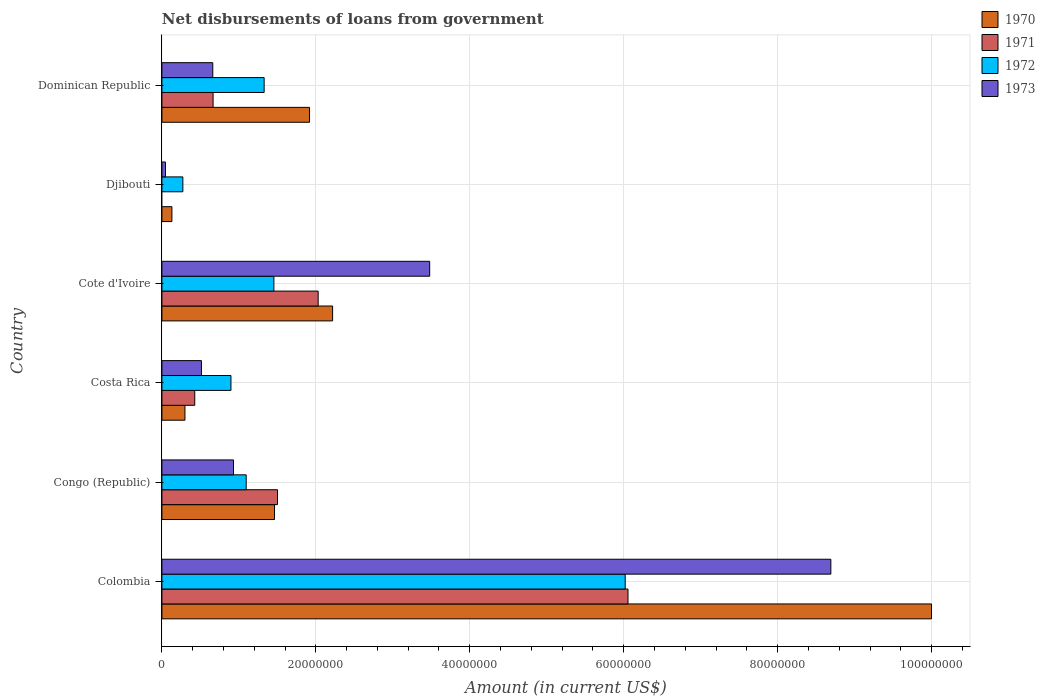How many different coloured bars are there?
Provide a succinct answer. 4. Are the number of bars per tick equal to the number of legend labels?
Your response must be concise. No. How many bars are there on the 3rd tick from the bottom?
Provide a succinct answer. 4. What is the label of the 6th group of bars from the top?
Keep it short and to the point. Colombia. What is the amount of loan disbursed from government in 1971 in Cote d'Ivoire?
Ensure brevity in your answer.  2.03e+07. Across all countries, what is the maximum amount of loan disbursed from government in 1973?
Offer a very short reply. 8.69e+07. Across all countries, what is the minimum amount of loan disbursed from government in 1971?
Make the answer very short. 0. In which country was the amount of loan disbursed from government in 1971 maximum?
Provide a succinct answer. Colombia. What is the total amount of loan disbursed from government in 1973 in the graph?
Keep it short and to the point. 1.43e+08. What is the difference between the amount of loan disbursed from government in 1973 in Colombia and that in Dominican Republic?
Ensure brevity in your answer.  8.03e+07. What is the difference between the amount of loan disbursed from government in 1970 in Dominican Republic and the amount of loan disbursed from government in 1972 in Djibouti?
Your answer should be very brief. 1.65e+07. What is the average amount of loan disbursed from government in 1971 per country?
Make the answer very short. 1.78e+07. What is the difference between the amount of loan disbursed from government in 1971 and amount of loan disbursed from government in 1973 in Dominican Republic?
Keep it short and to the point. 3.80e+04. In how many countries, is the amount of loan disbursed from government in 1970 greater than 68000000 US$?
Make the answer very short. 1. What is the ratio of the amount of loan disbursed from government in 1971 in Colombia to that in Costa Rica?
Give a very brief answer. 14.19. Is the amount of loan disbursed from government in 1970 in Costa Rica less than that in Dominican Republic?
Provide a succinct answer. Yes. Is the difference between the amount of loan disbursed from government in 1971 in Cote d'Ivoire and Dominican Republic greater than the difference between the amount of loan disbursed from government in 1973 in Cote d'Ivoire and Dominican Republic?
Ensure brevity in your answer.  No. What is the difference between the highest and the second highest amount of loan disbursed from government in 1970?
Provide a short and direct response. 7.78e+07. What is the difference between the highest and the lowest amount of loan disbursed from government in 1973?
Provide a succinct answer. 8.64e+07. In how many countries, is the amount of loan disbursed from government in 1971 greater than the average amount of loan disbursed from government in 1971 taken over all countries?
Offer a terse response. 2. How many bars are there?
Give a very brief answer. 23. Are all the bars in the graph horizontal?
Your answer should be very brief. Yes. Does the graph contain any zero values?
Provide a succinct answer. Yes. Does the graph contain grids?
Provide a succinct answer. Yes. How many legend labels are there?
Your response must be concise. 4. How are the legend labels stacked?
Your answer should be compact. Vertical. What is the title of the graph?
Make the answer very short. Net disbursements of loans from government. What is the label or title of the Y-axis?
Provide a short and direct response. Country. What is the Amount (in current US$) of 1970 in Colombia?
Offer a terse response. 1.00e+08. What is the Amount (in current US$) of 1971 in Colombia?
Give a very brief answer. 6.06e+07. What is the Amount (in current US$) in 1972 in Colombia?
Ensure brevity in your answer.  6.02e+07. What is the Amount (in current US$) in 1973 in Colombia?
Provide a succinct answer. 8.69e+07. What is the Amount (in current US$) in 1970 in Congo (Republic)?
Provide a short and direct response. 1.46e+07. What is the Amount (in current US$) in 1971 in Congo (Republic)?
Offer a very short reply. 1.50e+07. What is the Amount (in current US$) of 1972 in Congo (Republic)?
Your answer should be compact. 1.10e+07. What is the Amount (in current US$) of 1973 in Congo (Republic)?
Offer a terse response. 9.30e+06. What is the Amount (in current US$) of 1970 in Costa Rica?
Your answer should be compact. 3.00e+06. What is the Amount (in current US$) of 1971 in Costa Rica?
Offer a terse response. 4.27e+06. What is the Amount (in current US$) in 1972 in Costa Rica?
Your answer should be very brief. 8.97e+06. What is the Amount (in current US$) of 1973 in Costa Rica?
Offer a terse response. 5.14e+06. What is the Amount (in current US$) in 1970 in Cote d'Ivoire?
Your answer should be very brief. 2.22e+07. What is the Amount (in current US$) in 1971 in Cote d'Ivoire?
Give a very brief answer. 2.03e+07. What is the Amount (in current US$) of 1972 in Cote d'Ivoire?
Your response must be concise. 1.45e+07. What is the Amount (in current US$) in 1973 in Cote d'Ivoire?
Provide a short and direct response. 3.48e+07. What is the Amount (in current US$) of 1970 in Djibouti?
Provide a short and direct response. 1.30e+06. What is the Amount (in current US$) in 1971 in Djibouti?
Your answer should be compact. 0. What is the Amount (in current US$) of 1972 in Djibouti?
Your answer should be very brief. 2.72e+06. What is the Amount (in current US$) in 1973 in Djibouti?
Your response must be concise. 4.68e+05. What is the Amount (in current US$) in 1970 in Dominican Republic?
Your answer should be compact. 1.92e+07. What is the Amount (in current US$) in 1971 in Dominican Republic?
Your response must be concise. 6.65e+06. What is the Amount (in current US$) of 1972 in Dominican Republic?
Your response must be concise. 1.33e+07. What is the Amount (in current US$) in 1973 in Dominican Republic?
Give a very brief answer. 6.61e+06. Across all countries, what is the maximum Amount (in current US$) in 1970?
Your answer should be compact. 1.00e+08. Across all countries, what is the maximum Amount (in current US$) of 1971?
Your answer should be very brief. 6.06e+07. Across all countries, what is the maximum Amount (in current US$) of 1972?
Your answer should be compact. 6.02e+07. Across all countries, what is the maximum Amount (in current US$) of 1973?
Your response must be concise. 8.69e+07. Across all countries, what is the minimum Amount (in current US$) of 1970?
Offer a very short reply. 1.30e+06. Across all countries, what is the minimum Amount (in current US$) of 1971?
Your answer should be compact. 0. Across all countries, what is the minimum Amount (in current US$) of 1972?
Your answer should be very brief. 2.72e+06. Across all countries, what is the minimum Amount (in current US$) in 1973?
Provide a short and direct response. 4.68e+05. What is the total Amount (in current US$) in 1970 in the graph?
Provide a succinct answer. 1.60e+08. What is the total Amount (in current US$) of 1971 in the graph?
Offer a terse response. 1.07e+08. What is the total Amount (in current US$) of 1972 in the graph?
Keep it short and to the point. 1.11e+08. What is the total Amount (in current US$) of 1973 in the graph?
Your response must be concise. 1.43e+08. What is the difference between the Amount (in current US$) of 1970 in Colombia and that in Congo (Republic)?
Offer a terse response. 8.54e+07. What is the difference between the Amount (in current US$) of 1971 in Colombia and that in Congo (Republic)?
Your answer should be compact. 4.55e+07. What is the difference between the Amount (in current US$) in 1972 in Colombia and that in Congo (Republic)?
Your answer should be very brief. 4.92e+07. What is the difference between the Amount (in current US$) in 1973 in Colombia and that in Congo (Republic)?
Your answer should be compact. 7.76e+07. What is the difference between the Amount (in current US$) in 1970 in Colombia and that in Costa Rica?
Your response must be concise. 9.70e+07. What is the difference between the Amount (in current US$) in 1971 in Colombia and that in Costa Rica?
Provide a short and direct response. 5.63e+07. What is the difference between the Amount (in current US$) of 1972 in Colombia and that in Costa Rica?
Keep it short and to the point. 5.12e+07. What is the difference between the Amount (in current US$) in 1973 in Colombia and that in Costa Rica?
Provide a succinct answer. 8.18e+07. What is the difference between the Amount (in current US$) of 1970 in Colombia and that in Cote d'Ivoire?
Provide a succinct answer. 7.78e+07. What is the difference between the Amount (in current US$) in 1971 in Colombia and that in Cote d'Ivoire?
Make the answer very short. 4.03e+07. What is the difference between the Amount (in current US$) of 1972 in Colombia and that in Cote d'Ivoire?
Your response must be concise. 4.56e+07. What is the difference between the Amount (in current US$) in 1973 in Colombia and that in Cote d'Ivoire?
Your answer should be compact. 5.21e+07. What is the difference between the Amount (in current US$) in 1970 in Colombia and that in Djibouti?
Ensure brevity in your answer.  9.87e+07. What is the difference between the Amount (in current US$) in 1972 in Colombia and that in Djibouti?
Ensure brevity in your answer.  5.75e+07. What is the difference between the Amount (in current US$) in 1973 in Colombia and that in Djibouti?
Offer a terse response. 8.64e+07. What is the difference between the Amount (in current US$) of 1970 in Colombia and that in Dominican Republic?
Your answer should be compact. 8.08e+07. What is the difference between the Amount (in current US$) in 1971 in Colombia and that in Dominican Republic?
Give a very brief answer. 5.39e+07. What is the difference between the Amount (in current US$) of 1972 in Colombia and that in Dominican Republic?
Give a very brief answer. 4.69e+07. What is the difference between the Amount (in current US$) of 1973 in Colombia and that in Dominican Republic?
Provide a succinct answer. 8.03e+07. What is the difference between the Amount (in current US$) of 1970 in Congo (Republic) and that in Costa Rica?
Give a very brief answer. 1.16e+07. What is the difference between the Amount (in current US$) of 1971 in Congo (Republic) and that in Costa Rica?
Offer a terse response. 1.08e+07. What is the difference between the Amount (in current US$) of 1972 in Congo (Republic) and that in Costa Rica?
Make the answer very short. 1.98e+06. What is the difference between the Amount (in current US$) in 1973 in Congo (Republic) and that in Costa Rica?
Offer a terse response. 4.16e+06. What is the difference between the Amount (in current US$) of 1970 in Congo (Republic) and that in Cote d'Ivoire?
Your response must be concise. -7.54e+06. What is the difference between the Amount (in current US$) in 1971 in Congo (Republic) and that in Cote d'Ivoire?
Give a very brief answer. -5.28e+06. What is the difference between the Amount (in current US$) in 1972 in Congo (Republic) and that in Cote d'Ivoire?
Give a very brief answer. -3.60e+06. What is the difference between the Amount (in current US$) in 1973 in Congo (Republic) and that in Cote d'Ivoire?
Give a very brief answer. -2.55e+07. What is the difference between the Amount (in current US$) in 1970 in Congo (Republic) and that in Djibouti?
Give a very brief answer. 1.33e+07. What is the difference between the Amount (in current US$) of 1972 in Congo (Republic) and that in Djibouti?
Provide a short and direct response. 8.23e+06. What is the difference between the Amount (in current US$) of 1973 in Congo (Republic) and that in Djibouti?
Make the answer very short. 8.83e+06. What is the difference between the Amount (in current US$) in 1970 in Congo (Republic) and that in Dominican Republic?
Provide a succinct answer. -4.55e+06. What is the difference between the Amount (in current US$) of 1971 in Congo (Republic) and that in Dominican Republic?
Ensure brevity in your answer.  8.37e+06. What is the difference between the Amount (in current US$) in 1972 in Congo (Republic) and that in Dominican Republic?
Provide a succinct answer. -2.33e+06. What is the difference between the Amount (in current US$) of 1973 in Congo (Republic) and that in Dominican Republic?
Offer a very short reply. 2.69e+06. What is the difference between the Amount (in current US$) of 1970 in Costa Rica and that in Cote d'Ivoire?
Your answer should be compact. -1.92e+07. What is the difference between the Amount (in current US$) of 1971 in Costa Rica and that in Cote d'Ivoire?
Provide a short and direct response. -1.60e+07. What is the difference between the Amount (in current US$) of 1972 in Costa Rica and that in Cote d'Ivoire?
Ensure brevity in your answer.  -5.58e+06. What is the difference between the Amount (in current US$) in 1973 in Costa Rica and that in Cote d'Ivoire?
Make the answer very short. -2.97e+07. What is the difference between the Amount (in current US$) in 1970 in Costa Rica and that in Djibouti?
Your response must be concise. 1.70e+06. What is the difference between the Amount (in current US$) of 1972 in Costa Rica and that in Djibouti?
Make the answer very short. 6.25e+06. What is the difference between the Amount (in current US$) of 1973 in Costa Rica and that in Djibouti?
Make the answer very short. 4.67e+06. What is the difference between the Amount (in current US$) of 1970 in Costa Rica and that in Dominican Republic?
Give a very brief answer. -1.62e+07. What is the difference between the Amount (in current US$) of 1971 in Costa Rica and that in Dominican Republic?
Keep it short and to the point. -2.38e+06. What is the difference between the Amount (in current US$) of 1972 in Costa Rica and that in Dominican Republic?
Your response must be concise. -4.31e+06. What is the difference between the Amount (in current US$) in 1973 in Costa Rica and that in Dominican Republic?
Make the answer very short. -1.47e+06. What is the difference between the Amount (in current US$) in 1970 in Cote d'Ivoire and that in Djibouti?
Ensure brevity in your answer.  2.09e+07. What is the difference between the Amount (in current US$) in 1972 in Cote d'Ivoire and that in Djibouti?
Provide a succinct answer. 1.18e+07. What is the difference between the Amount (in current US$) in 1973 in Cote d'Ivoire and that in Djibouti?
Offer a very short reply. 3.43e+07. What is the difference between the Amount (in current US$) of 1970 in Cote d'Ivoire and that in Dominican Republic?
Provide a short and direct response. 3.00e+06. What is the difference between the Amount (in current US$) of 1971 in Cote d'Ivoire and that in Dominican Republic?
Keep it short and to the point. 1.37e+07. What is the difference between the Amount (in current US$) of 1972 in Cote d'Ivoire and that in Dominican Republic?
Give a very brief answer. 1.27e+06. What is the difference between the Amount (in current US$) in 1973 in Cote d'Ivoire and that in Dominican Republic?
Provide a succinct answer. 2.82e+07. What is the difference between the Amount (in current US$) of 1970 in Djibouti and that in Dominican Republic?
Provide a short and direct response. -1.79e+07. What is the difference between the Amount (in current US$) of 1972 in Djibouti and that in Dominican Republic?
Ensure brevity in your answer.  -1.06e+07. What is the difference between the Amount (in current US$) of 1973 in Djibouti and that in Dominican Republic?
Give a very brief answer. -6.14e+06. What is the difference between the Amount (in current US$) of 1970 in Colombia and the Amount (in current US$) of 1971 in Congo (Republic)?
Provide a short and direct response. 8.50e+07. What is the difference between the Amount (in current US$) in 1970 in Colombia and the Amount (in current US$) in 1972 in Congo (Republic)?
Make the answer very short. 8.90e+07. What is the difference between the Amount (in current US$) of 1970 in Colombia and the Amount (in current US$) of 1973 in Congo (Republic)?
Give a very brief answer. 9.07e+07. What is the difference between the Amount (in current US$) in 1971 in Colombia and the Amount (in current US$) in 1972 in Congo (Republic)?
Ensure brevity in your answer.  4.96e+07. What is the difference between the Amount (in current US$) of 1971 in Colombia and the Amount (in current US$) of 1973 in Congo (Republic)?
Offer a very short reply. 5.13e+07. What is the difference between the Amount (in current US$) of 1972 in Colombia and the Amount (in current US$) of 1973 in Congo (Republic)?
Ensure brevity in your answer.  5.09e+07. What is the difference between the Amount (in current US$) of 1970 in Colombia and the Amount (in current US$) of 1971 in Costa Rica?
Offer a very short reply. 9.57e+07. What is the difference between the Amount (in current US$) of 1970 in Colombia and the Amount (in current US$) of 1972 in Costa Rica?
Make the answer very short. 9.10e+07. What is the difference between the Amount (in current US$) of 1970 in Colombia and the Amount (in current US$) of 1973 in Costa Rica?
Ensure brevity in your answer.  9.49e+07. What is the difference between the Amount (in current US$) in 1971 in Colombia and the Amount (in current US$) in 1972 in Costa Rica?
Give a very brief answer. 5.16e+07. What is the difference between the Amount (in current US$) of 1971 in Colombia and the Amount (in current US$) of 1973 in Costa Rica?
Your answer should be very brief. 5.54e+07. What is the difference between the Amount (in current US$) of 1972 in Colombia and the Amount (in current US$) of 1973 in Costa Rica?
Give a very brief answer. 5.51e+07. What is the difference between the Amount (in current US$) of 1970 in Colombia and the Amount (in current US$) of 1971 in Cote d'Ivoire?
Your answer should be compact. 7.97e+07. What is the difference between the Amount (in current US$) in 1970 in Colombia and the Amount (in current US$) in 1972 in Cote d'Ivoire?
Your answer should be very brief. 8.54e+07. What is the difference between the Amount (in current US$) of 1970 in Colombia and the Amount (in current US$) of 1973 in Cote d'Ivoire?
Offer a very short reply. 6.52e+07. What is the difference between the Amount (in current US$) of 1971 in Colombia and the Amount (in current US$) of 1972 in Cote d'Ivoire?
Ensure brevity in your answer.  4.60e+07. What is the difference between the Amount (in current US$) in 1971 in Colombia and the Amount (in current US$) in 1973 in Cote d'Ivoire?
Provide a succinct answer. 2.58e+07. What is the difference between the Amount (in current US$) of 1972 in Colombia and the Amount (in current US$) of 1973 in Cote d'Ivoire?
Give a very brief answer. 2.54e+07. What is the difference between the Amount (in current US$) in 1970 in Colombia and the Amount (in current US$) in 1972 in Djibouti?
Offer a terse response. 9.73e+07. What is the difference between the Amount (in current US$) in 1970 in Colombia and the Amount (in current US$) in 1973 in Djibouti?
Offer a very short reply. 9.95e+07. What is the difference between the Amount (in current US$) in 1971 in Colombia and the Amount (in current US$) in 1972 in Djibouti?
Offer a terse response. 5.78e+07. What is the difference between the Amount (in current US$) of 1971 in Colombia and the Amount (in current US$) of 1973 in Djibouti?
Offer a very short reply. 6.01e+07. What is the difference between the Amount (in current US$) in 1972 in Colombia and the Amount (in current US$) in 1973 in Djibouti?
Give a very brief answer. 5.97e+07. What is the difference between the Amount (in current US$) of 1970 in Colombia and the Amount (in current US$) of 1971 in Dominican Republic?
Keep it short and to the point. 9.33e+07. What is the difference between the Amount (in current US$) in 1970 in Colombia and the Amount (in current US$) in 1972 in Dominican Republic?
Provide a short and direct response. 8.67e+07. What is the difference between the Amount (in current US$) in 1970 in Colombia and the Amount (in current US$) in 1973 in Dominican Republic?
Offer a very short reply. 9.34e+07. What is the difference between the Amount (in current US$) in 1971 in Colombia and the Amount (in current US$) in 1972 in Dominican Republic?
Give a very brief answer. 4.73e+07. What is the difference between the Amount (in current US$) in 1971 in Colombia and the Amount (in current US$) in 1973 in Dominican Republic?
Your response must be concise. 5.39e+07. What is the difference between the Amount (in current US$) in 1972 in Colombia and the Amount (in current US$) in 1973 in Dominican Republic?
Keep it short and to the point. 5.36e+07. What is the difference between the Amount (in current US$) of 1970 in Congo (Republic) and the Amount (in current US$) of 1971 in Costa Rica?
Provide a short and direct response. 1.04e+07. What is the difference between the Amount (in current US$) of 1970 in Congo (Republic) and the Amount (in current US$) of 1972 in Costa Rica?
Give a very brief answer. 5.66e+06. What is the difference between the Amount (in current US$) of 1970 in Congo (Republic) and the Amount (in current US$) of 1973 in Costa Rica?
Your response must be concise. 9.50e+06. What is the difference between the Amount (in current US$) in 1971 in Congo (Republic) and the Amount (in current US$) in 1972 in Costa Rica?
Your answer should be very brief. 6.05e+06. What is the difference between the Amount (in current US$) in 1971 in Congo (Republic) and the Amount (in current US$) in 1973 in Costa Rica?
Ensure brevity in your answer.  9.88e+06. What is the difference between the Amount (in current US$) in 1972 in Congo (Republic) and the Amount (in current US$) in 1973 in Costa Rica?
Make the answer very short. 5.81e+06. What is the difference between the Amount (in current US$) of 1970 in Congo (Republic) and the Amount (in current US$) of 1971 in Cote d'Ivoire?
Offer a very short reply. -5.67e+06. What is the difference between the Amount (in current US$) in 1970 in Congo (Republic) and the Amount (in current US$) in 1972 in Cote d'Ivoire?
Give a very brief answer. 8.50e+04. What is the difference between the Amount (in current US$) in 1970 in Congo (Republic) and the Amount (in current US$) in 1973 in Cote d'Ivoire?
Your response must be concise. -2.02e+07. What is the difference between the Amount (in current US$) in 1971 in Congo (Republic) and the Amount (in current US$) in 1972 in Cote d'Ivoire?
Keep it short and to the point. 4.73e+05. What is the difference between the Amount (in current US$) in 1971 in Congo (Republic) and the Amount (in current US$) in 1973 in Cote d'Ivoire?
Provide a succinct answer. -1.98e+07. What is the difference between the Amount (in current US$) in 1972 in Congo (Republic) and the Amount (in current US$) in 1973 in Cote d'Ivoire?
Provide a succinct answer. -2.38e+07. What is the difference between the Amount (in current US$) of 1970 in Congo (Republic) and the Amount (in current US$) of 1972 in Djibouti?
Make the answer very short. 1.19e+07. What is the difference between the Amount (in current US$) in 1970 in Congo (Republic) and the Amount (in current US$) in 1973 in Djibouti?
Offer a very short reply. 1.42e+07. What is the difference between the Amount (in current US$) in 1971 in Congo (Republic) and the Amount (in current US$) in 1972 in Djibouti?
Offer a terse response. 1.23e+07. What is the difference between the Amount (in current US$) of 1971 in Congo (Republic) and the Amount (in current US$) of 1973 in Djibouti?
Your answer should be very brief. 1.46e+07. What is the difference between the Amount (in current US$) in 1972 in Congo (Republic) and the Amount (in current US$) in 1973 in Djibouti?
Provide a succinct answer. 1.05e+07. What is the difference between the Amount (in current US$) in 1970 in Congo (Republic) and the Amount (in current US$) in 1971 in Dominican Republic?
Your response must be concise. 7.98e+06. What is the difference between the Amount (in current US$) of 1970 in Congo (Republic) and the Amount (in current US$) of 1972 in Dominican Republic?
Your response must be concise. 1.35e+06. What is the difference between the Amount (in current US$) in 1970 in Congo (Republic) and the Amount (in current US$) in 1973 in Dominican Republic?
Keep it short and to the point. 8.02e+06. What is the difference between the Amount (in current US$) of 1971 in Congo (Republic) and the Amount (in current US$) of 1972 in Dominican Republic?
Ensure brevity in your answer.  1.74e+06. What is the difference between the Amount (in current US$) of 1971 in Congo (Republic) and the Amount (in current US$) of 1973 in Dominican Republic?
Ensure brevity in your answer.  8.41e+06. What is the difference between the Amount (in current US$) in 1972 in Congo (Republic) and the Amount (in current US$) in 1973 in Dominican Republic?
Ensure brevity in your answer.  4.34e+06. What is the difference between the Amount (in current US$) of 1970 in Costa Rica and the Amount (in current US$) of 1971 in Cote d'Ivoire?
Make the answer very short. -1.73e+07. What is the difference between the Amount (in current US$) of 1970 in Costa Rica and the Amount (in current US$) of 1972 in Cote d'Ivoire?
Your answer should be very brief. -1.16e+07. What is the difference between the Amount (in current US$) of 1970 in Costa Rica and the Amount (in current US$) of 1973 in Cote d'Ivoire?
Offer a terse response. -3.18e+07. What is the difference between the Amount (in current US$) in 1971 in Costa Rica and the Amount (in current US$) in 1972 in Cote d'Ivoire?
Keep it short and to the point. -1.03e+07. What is the difference between the Amount (in current US$) of 1971 in Costa Rica and the Amount (in current US$) of 1973 in Cote d'Ivoire?
Give a very brief answer. -3.05e+07. What is the difference between the Amount (in current US$) in 1972 in Costa Rica and the Amount (in current US$) in 1973 in Cote d'Ivoire?
Your answer should be very brief. -2.58e+07. What is the difference between the Amount (in current US$) of 1970 in Costa Rica and the Amount (in current US$) of 1972 in Djibouti?
Give a very brief answer. 2.73e+05. What is the difference between the Amount (in current US$) in 1970 in Costa Rica and the Amount (in current US$) in 1973 in Djibouti?
Keep it short and to the point. 2.53e+06. What is the difference between the Amount (in current US$) in 1971 in Costa Rica and the Amount (in current US$) in 1972 in Djibouti?
Your answer should be compact. 1.55e+06. What is the difference between the Amount (in current US$) of 1971 in Costa Rica and the Amount (in current US$) of 1973 in Djibouti?
Your response must be concise. 3.80e+06. What is the difference between the Amount (in current US$) in 1972 in Costa Rica and the Amount (in current US$) in 1973 in Djibouti?
Your answer should be very brief. 8.50e+06. What is the difference between the Amount (in current US$) of 1970 in Costa Rica and the Amount (in current US$) of 1971 in Dominican Republic?
Your answer should be very brief. -3.65e+06. What is the difference between the Amount (in current US$) in 1970 in Costa Rica and the Amount (in current US$) in 1972 in Dominican Republic?
Your answer should be very brief. -1.03e+07. What is the difference between the Amount (in current US$) of 1970 in Costa Rica and the Amount (in current US$) of 1973 in Dominican Republic?
Make the answer very short. -3.62e+06. What is the difference between the Amount (in current US$) of 1971 in Costa Rica and the Amount (in current US$) of 1972 in Dominican Republic?
Make the answer very short. -9.01e+06. What is the difference between the Amount (in current US$) in 1971 in Costa Rica and the Amount (in current US$) in 1973 in Dominican Republic?
Make the answer very short. -2.34e+06. What is the difference between the Amount (in current US$) in 1972 in Costa Rica and the Amount (in current US$) in 1973 in Dominican Republic?
Give a very brief answer. 2.36e+06. What is the difference between the Amount (in current US$) in 1970 in Cote d'Ivoire and the Amount (in current US$) in 1972 in Djibouti?
Make the answer very short. 1.95e+07. What is the difference between the Amount (in current US$) in 1970 in Cote d'Ivoire and the Amount (in current US$) in 1973 in Djibouti?
Provide a short and direct response. 2.17e+07. What is the difference between the Amount (in current US$) of 1971 in Cote d'Ivoire and the Amount (in current US$) of 1972 in Djibouti?
Give a very brief answer. 1.76e+07. What is the difference between the Amount (in current US$) in 1971 in Cote d'Ivoire and the Amount (in current US$) in 1973 in Djibouti?
Provide a succinct answer. 1.98e+07. What is the difference between the Amount (in current US$) of 1972 in Cote d'Ivoire and the Amount (in current US$) of 1973 in Djibouti?
Provide a succinct answer. 1.41e+07. What is the difference between the Amount (in current US$) of 1970 in Cote d'Ivoire and the Amount (in current US$) of 1971 in Dominican Republic?
Offer a very short reply. 1.55e+07. What is the difference between the Amount (in current US$) of 1970 in Cote d'Ivoire and the Amount (in current US$) of 1972 in Dominican Republic?
Keep it short and to the point. 8.90e+06. What is the difference between the Amount (in current US$) of 1970 in Cote d'Ivoire and the Amount (in current US$) of 1973 in Dominican Republic?
Give a very brief answer. 1.56e+07. What is the difference between the Amount (in current US$) in 1971 in Cote d'Ivoire and the Amount (in current US$) in 1972 in Dominican Republic?
Provide a succinct answer. 7.02e+06. What is the difference between the Amount (in current US$) in 1971 in Cote d'Ivoire and the Amount (in current US$) in 1973 in Dominican Republic?
Provide a short and direct response. 1.37e+07. What is the difference between the Amount (in current US$) of 1972 in Cote d'Ivoire and the Amount (in current US$) of 1973 in Dominican Republic?
Keep it short and to the point. 7.94e+06. What is the difference between the Amount (in current US$) in 1970 in Djibouti and the Amount (in current US$) in 1971 in Dominican Republic?
Provide a short and direct response. -5.35e+06. What is the difference between the Amount (in current US$) in 1970 in Djibouti and the Amount (in current US$) in 1972 in Dominican Republic?
Keep it short and to the point. -1.20e+07. What is the difference between the Amount (in current US$) in 1970 in Djibouti and the Amount (in current US$) in 1973 in Dominican Republic?
Your answer should be very brief. -5.31e+06. What is the difference between the Amount (in current US$) in 1972 in Djibouti and the Amount (in current US$) in 1973 in Dominican Republic?
Your response must be concise. -3.89e+06. What is the average Amount (in current US$) of 1970 per country?
Ensure brevity in your answer.  2.67e+07. What is the average Amount (in current US$) of 1971 per country?
Make the answer very short. 1.78e+07. What is the average Amount (in current US$) in 1972 per country?
Offer a very short reply. 1.84e+07. What is the average Amount (in current US$) of 1973 per country?
Ensure brevity in your answer.  2.39e+07. What is the difference between the Amount (in current US$) of 1970 and Amount (in current US$) of 1971 in Colombia?
Offer a terse response. 3.94e+07. What is the difference between the Amount (in current US$) in 1970 and Amount (in current US$) in 1972 in Colombia?
Your answer should be very brief. 3.98e+07. What is the difference between the Amount (in current US$) of 1970 and Amount (in current US$) of 1973 in Colombia?
Your response must be concise. 1.31e+07. What is the difference between the Amount (in current US$) in 1971 and Amount (in current US$) in 1972 in Colombia?
Your answer should be compact. 3.62e+05. What is the difference between the Amount (in current US$) of 1971 and Amount (in current US$) of 1973 in Colombia?
Offer a terse response. -2.64e+07. What is the difference between the Amount (in current US$) in 1972 and Amount (in current US$) in 1973 in Colombia?
Give a very brief answer. -2.67e+07. What is the difference between the Amount (in current US$) of 1970 and Amount (in current US$) of 1971 in Congo (Republic)?
Offer a very short reply. -3.88e+05. What is the difference between the Amount (in current US$) in 1970 and Amount (in current US$) in 1972 in Congo (Republic)?
Provide a short and direct response. 3.68e+06. What is the difference between the Amount (in current US$) in 1970 and Amount (in current US$) in 1973 in Congo (Republic)?
Provide a short and direct response. 5.33e+06. What is the difference between the Amount (in current US$) of 1971 and Amount (in current US$) of 1972 in Congo (Republic)?
Provide a succinct answer. 4.07e+06. What is the difference between the Amount (in current US$) in 1971 and Amount (in current US$) in 1973 in Congo (Republic)?
Your response must be concise. 5.72e+06. What is the difference between the Amount (in current US$) of 1972 and Amount (in current US$) of 1973 in Congo (Republic)?
Ensure brevity in your answer.  1.65e+06. What is the difference between the Amount (in current US$) in 1970 and Amount (in current US$) in 1971 in Costa Rica?
Keep it short and to the point. -1.27e+06. What is the difference between the Amount (in current US$) of 1970 and Amount (in current US$) of 1972 in Costa Rica?
Your answer should be very brief. -5.98e+06. What is the difference between the Amount (in current US$) of 1970 and Amount (in current US$) of 1973 in Costa Rica?
Offer a very short reply. -2.14e+06. What is the difference between the Amount (in current US$) in 1971 and Amount (in current US$) in 1972 in Costa Rica?
Provide a short and direct response. -4.70e+06. What is the difference between the Amount (in current US$) in 1971 and Amount (in current US$) in 1973 in Costa Rica?
Give a very brief answer. -8.68e+05. What is the difference between the Amount (in current US$) in 1972 and Amount (in current US$) in 1973 in Costa Rica?
Offer a terse response. 3.84e+06. What is the difference between the Amount (in current US$) in 1970 and Amount (in current US$) in 1971 in Cote d'Ivoire?
Give a very brief answer. 1.88e+06. What is the difference between the Amount (in current US$) in 1970 and Amount (in current US$) in 1972 in Cote d'Ivoire?
Offer a very short reply. 7.63e+06. What is the difference between the Amount (in current US$) of 1970 and Amount (in current US$) of 1973 in Cote d'Ivoire?
Ensure brevity in your answer.  -1.26e+07. What is the difference between the Amount (in current US$) of 1971 and Amount (in current US$) of 1972 in Cote d'Ivoire?
Provide a short and direct response. 5.75e+06. What is the difference between the Amount (in current US$) in 1971 and Amount (in current US$) in 1973 in Cote d'Ivoire?
Your response must be concise. -1.45e+07. What is the difference between the Amount (in current US$) in 1972 and Amount (in current US$) in 1973 in Cote d'Ivoire?
Your answer should be very brief. -2.02e+07. What is the difference between the Amount (in current US$) in 1970 and Amount (in current US$) in 1972 in Djibouti?
Provide a short and direct response. -1.42e+06. What is the difference between the Amount (in current US$) in 1970 and Amount (in current US$) in 1973 in Djibouti?
Offer a very short reply. 8.32e+05. What is the difference between the Amount (in current US$) in 1972 and Amount (in current US$) in 1973 in Djibouti?
Offer a very short reply. 2.26e+06. What is the difference between the Amount (in current US$) in 1970 and Amount (in current US$) in 1971 in Dominican Republic?
Ensure brevity in your answer.  1.25e+07. What is the difference between the Amount (in current US$) of 1970 and Amount (in current US$) of 1972 in Dominican Republic?
Your answer should be very brief. 5.90e+06. What is the difference between the Amount (in current US$) in 1970 and Amount (in current US$) in 1973 in Dominican Republic?
Offer a terse response. 1.26e+07. What is the difference between the Amount (in current US$) in 1971 and Amount (in current US$) in 1972 in Dominican Republic?
Offer a very short reply. -6.63e+06. What is the difference between the Amount (in current US$) in 1971 and Amount (in current US$) in 1973 in Dominican Republic?
Your response must be concise. 3.80e+04. What is the difference between the Amount (in current US$) of 1972 and Amount (in current US$) of 1973 in Dominican Republic?
Your answer should be compact. 6.67e+06. What is the ratio of the Amount (in current US$) in 1970 in Colombia to that in Congo (Republic)?
Your response must be concise. 6.83. What is the ratio of the Amount (in current US$) in 1971 in Colombia to that in Congo (Republic)?
Provide a succinct answer. 4.03. What is the ratio of the Amount (in current US$) of 1972 in Colombia to that in Congo (Republic)?
Offer a very short reply. 5.5. What is the ratio of the Amount (in current US$) of 1973 in Colombia to that in Congo (Republic)?
Provide a succinct answer. 9.34. What is the ratio of the Amount (in current US$) in 1970 in Colombia to that in Costa Rica?
Provide a succinct answer. 33.38. What is the ratio of the Amount (in current US$) in 1971 in Colombia to that in Costa Rica?
Provide a short and direct response. 14.19. What is the ratio of the Amount (in current US$) of 1972 in Colombia to that in Costa Rica?
Your answer should be very brief. 6.71. What is the ratio of the Amount (in current US$) in 1973 in Colombia to that in Costa Rica?
Your answer should be compact. 16.92. What is the ratio of the Amount (in current US$) of 1970 in Colombia to that in Cote d'Ivoire?
Keep it short and to the point. 4.51. What is the ratio of the Amount (in current US$) of 1971 in Colombia to that in Cote d'Ivoire?
Your response must be concise. 2.98. What is the ratio of the Amount (in current US$) in 1972 in Colombia to that in Cote d'Ivoire?
Offer a very short reply. 4.14. What is the ratio of the Amount (in current US$) of 1973 in Colombia to that in Cote d'Ivoire?
Make the answer very short. 2.5. What is the ratio of the Amount (in current US$) of 1970 in Colombia to that in Djibouti?
Your answer should be very brief. 76.92. What is the ratio of the Amount (in current US$) of 1972 in Colombia to that in Djibouti?
Your response must be concise. 22.11. What is the ratio of the Amount (in current US$) of 1973 in Colombia to that in Djibouti?
Provide a short and direct response. 185.71. What is the ratio of the Amount (in current US$) in 1970 in Colombia to that in Dominican Republic?
Offer a very short reply. 5.21. What is the ratio of the Amount (in current US$) of 1971 in Colombia to that in Dominican Republic?
Keep it short and to the point. 9.11. What is the ratio of the Amount (in current US$) in 1972 in Colombia to that in Dominican Republic?
Your answer should be compact. 4.53. What is the ratio of the Amount (in current US$) in 1973 in Colombia to that in Dominican Republic?
Make the answer very short. 13.15. What is the ratio of the Amount (in current US$) of 1970 in Congo (Republic) to that in Costa Rica?
Your answer should be compact. 4.88. What is the ratio of the Amount (in current US$) of 1971 in Congo (Republic) to that in Costa Rica?
Provide a short and direct response. 3.52. What is the ratio of the Amount (in current US$) in 1972 in Congo (Republic) to that in Costa Rica?
Offer a very short reply. 1.22. What is the ratio of the Amount (in current US$) of 1973 in Congo (Republic) to that in Costa Rica?
Give a very brief answer. 1.81. What is the ratio of the Amount (in current US$) of 1970 in Congo (Republic) to that in Cote d'Ivoire?
Offer a terse response. 0.66. What is the ratio of the Amount (in current US$) of 1971 in Congo (Republic) to that in Cote d'Ivoire?
Make the answer very short. 0.74. What is the ratio of the Amount (in current US$) of 1972 in Congo (Republic) to that in Cote d'Ivoire?
Your answer should be very brief. 0.75. What is the ratio of the Amount (in current US$) of 1973 in Congo (Republic) to that in Cote d'Ivoire?
Keep it short and to the point. 0.27. What is the ratio of the Amount (in current US$) in 1970 in Congo (Republic) to that in Djibouti?
Your response must be concise. 11.26. What is the ratio of the Amount (in current US$) of 1972 in Congo (Republic) to that in Djibouti?
Your answer should be compact. 4.02. What is the ratio of the Amount (in current US$) in 1973 in Congo (Republic) to that in Djibouti?
Your answer should be very brief. 19.88. What is the ratio of the Amount (in current US$) in 1970 in Congo (Republic) to that in Dominican Republic?
Ensure brevity in your answer.  0.76. What is the ratio of the Amount (in current US$) in 1971 in Congo (Republic) to that in Dominican Republic?
Keep it short and to the point. 2.26. What is the ratio of the Amount (in current US$) of 1972 in Congo (Republic) to that in Dominican Republic?
Keep it short and to the point. 0.82. What is the ratio of the Amount (in current US$) in 1973 in Congo (Republic) to that in Dominican Republic?
Your response must be concise. 1.41. What is the ratio of the Amount (in current US$) in 1970 in Costa Rica to that in Cote d'Ivoire?
Give a very brief answer. 0.14. What is the ratio of the Amount (in current US$) in 1971 in Costa Rica to that in Cote d'Ivoire?
Give a very brief answer. 0.21. What is the ratio of the Amount (in current US$) of 1972 in Costa Rica to that in Cote d'Ivoire?
Make the answer very short. 0.62. What is the ratio of the Amount (in current US$) in 1973 in Costa Rica to that in Cote d'Ivoire?
Offer a terse response. 0.15. What is the ratio of the Amount (in current US$) in 1970 in Costa Rica to that in Djibouti?
Offer a terse response. 2.3. What is the ratio of the Amount (in current US$) in 1972 in Costa Rica to that in Djibouti?
Ensure brevity in your answer.  3.29. What is the ratio of the Amount (in current US$) of 1973 in Costa Rica to that in Djibouti?
Your response must be concise. 10.98. What is the ratio of the Amount (in current US$) of 1970 in Costa Rica to that in Dominican Republic?
Keep it short and to the point. 0.16. What is the ratio of the Amount (in current US$) of 1971 in Costa Rica to that in Dominican Republic?
Your answer should be very brief. 0.64. What is the ratio of the Amount (in current US$) in 1972 in Costa Rica to that in Dominican Republic?
Provide a short and direct response. 0.68. What is the ratio of the Amount (in current US$) of 1973 in Costa Rica to that in Dominican Republic?
Keep it short and to the point. 0.78. What is the ratio of the Amount (in current US$) of 1970 in Cote d'Ivoire to that in Djibouti?
Provide a succinct answer. 17.06. What is the ratio of the Amount (in current US$) of 1972 in Cote d'Ivoire to that in Djibouti?
Keep it short and to the point. 5.34. What is the ratio of the Amount (in current US$) in 1973 in Cote d'Ivoire to that in Djibouti?
Provide a short and direct response. 74.34. What is the ratio of the Amount (in current US$) in 1970 in Cote d'Ivoire to that in Dominican Republic?
Make the answer very short. 1.16. What is the ratio of the Amount (in current US$) in 1971 in Cote d'Ivoire to that in Dominican Republic?
Offer a very short reply. 3.05. What is the ratio of the Amount (in current US$) of 1972 in Cote d'Ivoire to that in Dominican Republic?
Keep it short and to the point. 1.1. What is the ratio of the Amount (in current US$) of 1973 in Cote d'Ivoire to that in Dominican Republic?
Ensure brevity in your answer.  5.26. What is the ratio of the Amount (in current US$) in 1970 in Djibouti to that in Dominican Republic?
Your answer should be compact. 0.07. What is the ratio of the Amount (in current US$) in 1972 in Djibouti to that in Dominican Republic?
Keep it short and to the point. 0.2. What is the ratio of the Amount (in current US$) in 1973 in Djibouti to that in Dominican Republic?
Provide a short and direct response. 0.07. What is the difference between the highest and the second highest Amount (in current US$) in 1970?
Provide a succinct answer. 7.78e+07. What is the difference between the highest and the second highest Amount (in current US$) of 1971?
Make the answer very short. 4.03e+07. What is the difference between the highest and the second highest Amount (in current US$) of 1972?
Your answer should be compact. 4.56e+07. What is the difference between the highest and the second highest Amount (in current US$) of 1973?
Make the answer very short. 5.21e+07. What is the difference between the highest and the lowest Amount (in current US$) of 1970?
Keep it short and to the point. 9.87e+07. What is the difference between the highest and the lowest Amount (in current US$) in 1971?
Provide a succinct answer. 6.06e+07. What is the difference between the highest and the lowest Amount (in current US$) in 1972?
Offer a very short reply. 5.75e+07. What is the difference between the highest and the lowest Amount (in current US$) in 1973?
Ensure brevity in your answer.  8.64e+07. 